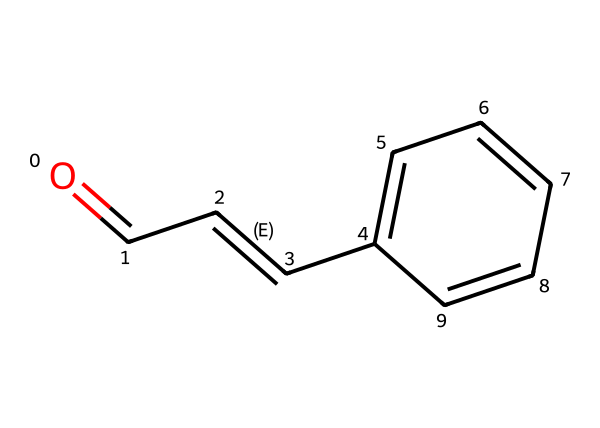How many carbon atoms are in cinnamaldehyde? By inspecting the SMILES representation, we identify a total of eight carbon atoms represented by the characters 'C' in the structure.
Answer: eight What functional group is present in cinnamaldehyde? The presence of the carbonyl group (C=O) at the beginning of the structure indicates that cinnamaldehyde contains an aldehyde functional group.
Answer: aldehyde What is the molecular formula of cinnamaldehyde? By counting the atoms from the SMILES, we find 8 carbon atoms, 8 hydrogen atoms, and 1 oxygen atom, leading to the molecular formula C8H8O.
Answer: C8H8O How many double bonds are present in cinnamaldehyde? The structure indicates there are two double bonds: one between the carbonyl carbon and oxygen, and another between the second and third carbon in the chain (C=C).
Answer: two What type of isomerism can cinnamaldehyde exhibit? Considering the presence of a double bond (C=C) in the structure, cinnamaldehyde can exhibit geometric (cis/trans) isomerism due to the restricted rotation around the double bond.
Answer: geometric Which part of the structure gives cinnamaldehyde its aroma? The presence of the aromatic ring (the 'c' characters in the structure) typically contributes to the characteristic smell of compounds like cinnamaldehyde.
Answer: aromatic ring What property makes cinnamaldehyde reactive compared to other hydrocarbons? The aldehyde functional group (C=O) is more polar than non-polar hydrocarbons, making cinnamaldehyde more reactive, particularly in nucleophilic addition reactions.
Answer: polarity 